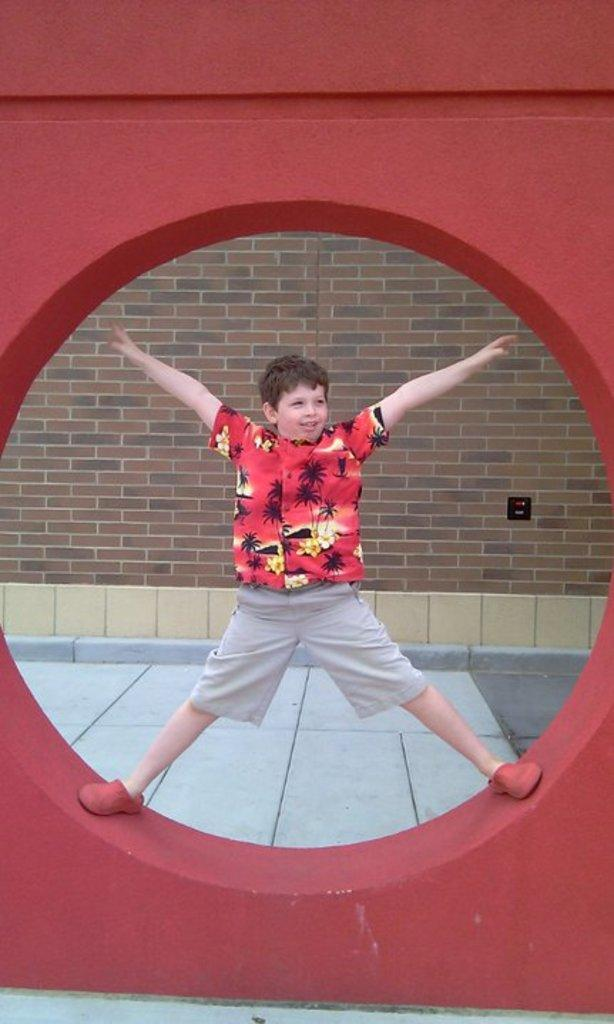What is the main subject of the image? The main subject of the image is a child. What is the child doing in the image? The child is stretching his hands and legs in the image. Where is the child located in the image? The child is standing in a circle of an architectural structure in the image. What is the architectural structure's purpose in the image? The architectural structure is present over a place in the image. How does the child appear to feel in the image? The child is smiling in the image. What type of meal is the child eating in the image? There is no meal present in the image; the child is stretching their hands and legs. Can you describe the cushion the child is sitting on in the image? There is no cushion present in the image; the child is standing in a circle of an architectural structure. 